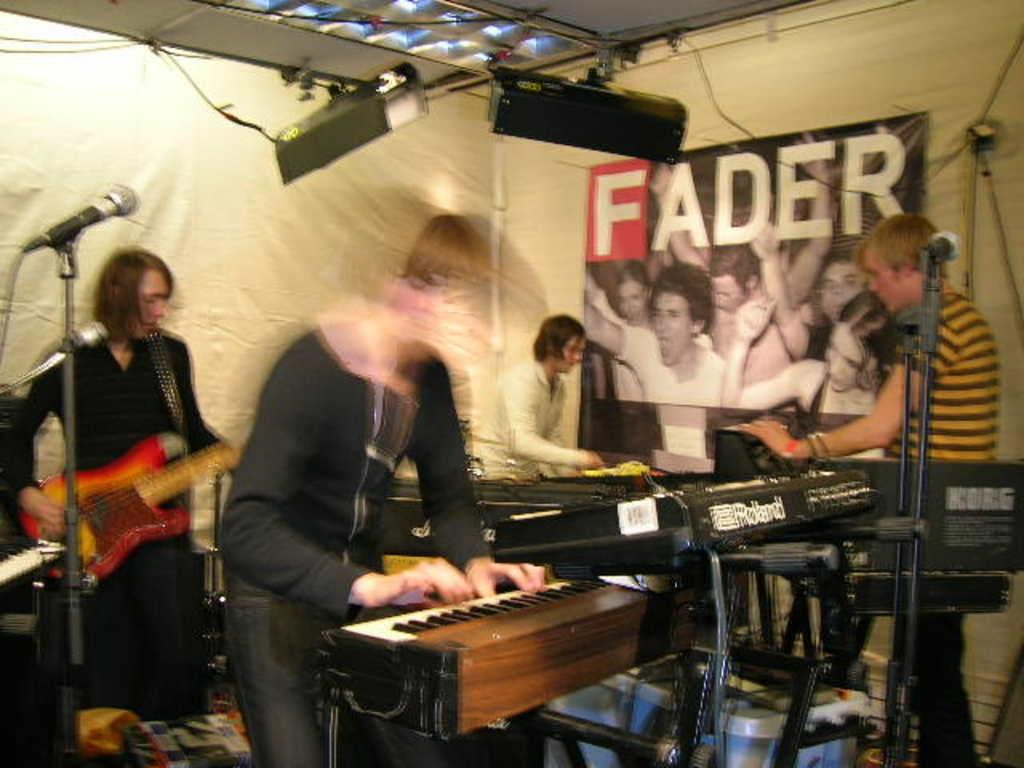How many people are in the image? There are four people in the image. What are the people doing in the image? The people are playing music. Can you describe the musical instruments being used? One person is holding a guitar, and another person is playing the piano. What else can be seen in the image besides the people and instruments? There are lights and a poster in the image. What type of linen is being used to clean the instruments in the image? There is no linen or cleaning activity depicted in the image. 